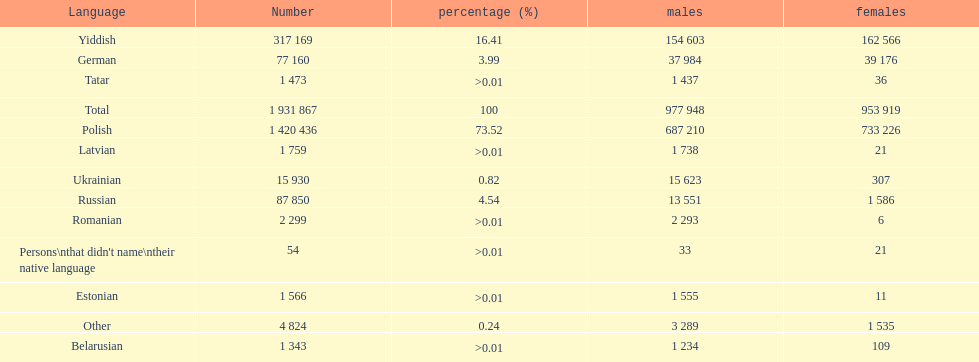The least amount of females Romanian. 